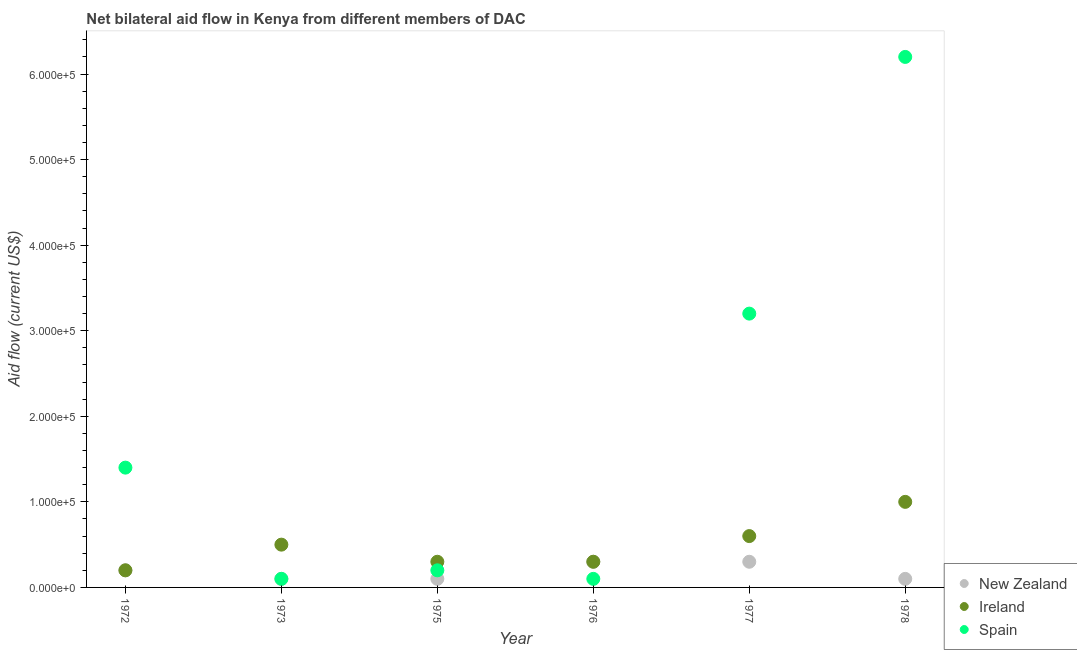How many different coloured dotlines are there?
Your answer should be very brief. 3. Is the number of dotlines equal to the number of legend labels?
Keep it short and to the point. Yes. What is the amount of aid provided by new zealand in 1972?
Offer a terse response. 2.00e+04. Across all years, what is the maximum amount of aid provided by spain?
Your answer should be compact. 6.20e+05. Across all years, what is the minimum amount of aid provided by new zealand?
Ensure brevity in your answer.  10000. In which year was the amount of aid provided by spain maximum?
Provide a succinct answer. 1978. In which year was the amount of aid provided by new zealand minimum?
Give a very brief answer. 1973. What is the total amount of aid provided by spain in the graph?
Give a very brief answer. 1.12e+06. What is the difference between the amount of aid provided by spain in 1976 and that in 1977?
Give a very brief answer. -3.10e+05. What is the difference between the amount of aid provided by spain in 1975 and the amount of aid provided by ireland in 1973?
Keep it short and to the point. -3.00e+04. What is the average amount of aid provided by spain per year?
Your answer should be very brief. 1.87e+05. In the year 1978, what is the difference between the amount of aid provided by new zealand and amount of aid provided by spain?
Ensure brevity in your answer.  -6.10e+05. In how many years, is the amount of aid provided by ireland greater than 480000 US$?
Provide a succinct answer. 0. Is the difference between the amount of aid provided by ireland in 1975 and 1978 greater than the difference between the amount of aid provided by new zealand in 1975 and 1978?
Offer a very short reply. No. What is the difference between the highest and the second highest amount of aid provided by new zealand?
Keep it short and to the point. 0. What is the difference between the highest and the lowest amount of aid provided by spain?
Your response must be concise. 6.10e+05. Is it the case that in every year, the sum of the amount of aid provided by new zealand and amount of aid provided by ireland is greater than the amount of aid provided by spain?
Offer a very short reply. No. How many years are there in the graph?
Offer a very short reply. 6. Does the graph contain any zero values?
Make the answer very short. No. How are the legend labels stacked?
Your answer should be very brief. Vertical. What is the title of the graph?
Your answer should be compact. Net bilateral aid flow in Kenya from different members of DAC. What is the label or title of the Y-axis?
Your answer should be very brief. Aid flow (current US$). What is the Aid flow (current US$) in New Zealand in 1972?
Offer a very short reply. 2.00e+04. What is the Aid flow (current US$) of Ireland in 1972?
Make the answer very short. 2.00e+04. What is the Aid flow (current US$) of Spain in 1972?
Your answer should be compact. 1.40e+05. What is the Aid flow (current US$) in New Zealand in 1973?
Keep it short and to the point. 10000. What is the Aid flow (current US$) in Ireland in 1973?
Offer a very short reply. 5.00e+04. What is the Aid flow (current US$) in Spain in 1973?
Provide a succinct answer. 10000. What is the Aid flow (current US$) in New Zealand in 1975?
Provide a short and direct response. 10000. What is the Aid flow (current US$) in Spain in 1975?
Ensure brevity in your answer.  2.00e+04. What is the Aid flow (current US$) of New Zealand in 1976?
Keep it short and to the point. 3.00e+04. What is the Aid flow (current US$) in Spain in 1976?
Your answer should be compact. 10000. What is the Aid flow (current US$) in New Zealand in 1977?
Give a very brief answer. 3.00e+04. What is the Aid flow (current US$) in Ireland in 1977?
Your answer should be very brief. 6.00e+04. What is the Aid flow (current US$) in Spain in 1977?
Ensure brevity in your answer.  3.20e+05. What is the Aid flow (current US$) in New Zealand in 1978?
Your response must be concise. 10000. What is the Aid flow (current US$) of Spain in 1978?
Your response must be concise. 6.20e+05. Across all years, what is the maximum Aid flow (current US$) of New Zealand?
Keep it short and to the point. 3.00e+04. Across all years, what is the maximum Aid flow (current US$) in Spain?
Provide a succinct answer. 6.20e+05. Across all years, what is the minimum Aid flow (current US$) in Spain?
Offer a very short reply. 10000. What is the total Aid flow (current US$) in New Zealand in the graph?
Make the answer very short. 1.10e+05. What is the total Aid flow (current US$) in Spain in the graph?
Ensure brevity in your answer.  1.12e+06. What is the difference between the Aid flow (current US$) in New Zealand in 1972 and that in 1973?
Offer a very short reply. 10000. What is the difference between the Aid flow (current US$) of Ireland in 1972 and that in 1973?
Provide a succinct answer. -3.00e+04. What is the difference between the Aid flow (current US$) of Spain in 1972 and that in 1973?
Offer a terse response. 1.30e+05. What is the difference between the Aid flow (current US$) of Ireland in 1972 and that in 1975?
Offer a terse response. -10000. What is the difference between the Aid flow (current US$) of Ireland in 1972 and that in 1976?
Offer a terse response. -10000. What is the difference between the Aid flow (current US$) in Spain in 1972 and that in 1976?
Ensure brevity in your answer.  1.30e+05. What is the difference between the Aid flow (current US$) of Ireland in 1972 and that in 1977?
Offer a very short reply. -4.00e+04. What is the difference between the Aid flow (current US$) of Spain in 1972 and that in 1978?
Your answer should be very brief. -4.80e+05. What is the difference between the Aid flow (current US$) in New Zealand in 1973 and that in 1976?
Provide a short and direct response. -2.00e+04. What is the difference between the Aid flow (current US$) in Ireland in 1973 and that in 1976?
Your response must be concise. 2.00e+04. What is the difference between the Aid flow (current US$) in Spain in 1973 and that in 1976?
Your answer should be compact. 0. What is the difference between the Aid flow (current US$) of New Zealand in 1973 and that in 1977?
Provide a succinct answer. -2.00e+04. What is the difference between the Aid flow (current US$) of Spain in 1973 and that in 1977?
Make the answer very short. -3.10e+05. What is the difference between the Aid flow (current US$) in New Zealand in 1973 and that in 1978?
Keep it short and to the point. 0. What is the difference between the Aid flow (current US$) in Spain in 1973 and that in 1978?
Give a very brief answer. -6.10e+05. What is the difference between the Aid flow (current US$) in Ireland in 1975 and that in 1976?
Keep it short and to the point. 0. What is the difference between the Aid flow (current US$) of Spain in 1975 and that in 1976?
Keep it short and to the point. 10000. What is the difference between the Aid flow (current US$) of New Zealand in 1975 and that in 1977?
Your response must be concise. -2.00e+04. What is the difference between the Aid flow (current US$) of Spain in 1975 and that in 1978?
Your answer should be compact. -6.00e+05. What is the difference between the Aid flow (current US$) of New Zealand in 1976 and that in 1977?
Provide a short and direct response. 0. What is the difference between the Aid flow (current US$) in Spain in 1976 and that in 1977?
Your answer should be compact. -3.10e+05. What is the difference between the Aid flow (current US$) of Spain in 1976 and that in 1978?
Your answer should be compact. -6.10e+05. What is the difference between the Aid flow (current US$) of New Zealand in 1977 and that in 1978?
Your response must be concise. 2.00e+04. What is the difference between the Aid flow (current US$) in Ireland in 1977 and that in 1978?
Offer a terse response. -4.00e+04. What is the difference between the Aid flow (current US$) of Ireland in 1972 and the Aid flow (current US$) of Spain in 1973?
Your answer should be compact. 10000. What is the difference between the Aid flow (current US$) of New Zealand in 1972 and the Aid flow (current US$) of Ireland in 1975?
Your answer should be compact. -10000. What is the difference between the Aid flow (current US$) of New Zealand in 1972 and the Aid flow (current US$) of Spain in 1975?
Keep it short and to the point. 0. What is the difference between the Aid flow (current US$) in New Zealand in 1972 and the Aid flow (current US$) in Spain in 1976?
Provide a short and direct response. 10000. What is the difference between the Aid flow (current US$) in Ireland in 1972 and the Aid flow (current US$) in Spain in 1976?
Ensure brevity in your answer.  10000. What is the difference between the Aid flow (current US$) of Ireland in 1972 and the Aid flow (current US$) of Spain in 1977?
Your response must be concise. -3.00e+05. What is the difference between the Aid flow (current US$) in New Zealand in 1972 and the Aid flow (current US$) in Spain in 1978?
Provide a succinct answer. -6.00e+05. What is the difference between the Aid flow (current US$) of Ireland in 1972 and the Aid flow (current US$) of Spain in 1978?
Offer a terse response. -6.00e+05. What is the difference between the Aid flow (current US$) in New Zealand in 1973 and the Aid flow (current US$) in Spain in 1975?
Your response must be concise. -10000. What is the difference between the Aid flow (current US$) in New Zealand in 1973 and the Aid flow (current US$) in Ireland in 1976?
Provide a succinct answer. -2.00e+04. What is the difference between the Aid flow (current US$) of New Zealand in 1973 and the Aid flow (current US$) of Spain in 1977?
Offer a terse response. -3.10e+05. What is the difference between the Aid flow (current US$) of New Zealand in 1973 and the Aid flow (current US$) of Spain in 1978?
Your answer should be very brief. -6.10e+05. What is the difference between the Aid flow (current US$) of Ireland in 1973 and the Aid flow (current US$) of Spain in 1978?
Your response must be concise. -5.70e+05. What is the difference between the Aid flow (current US$) of New Zealand in 1975 and the Aid flow (current US$) of Ireland in 1976?
Your response must be concise. -2.00e+04. What is the difference between the Aid flow (current US$) in New Zealand in 1975 and the Aid flow (current US$) in Spain in 1977?
Your response must be concise. -3.10e+05. What is the difference between the Aid flow (current US$) in New Zealand in 1975 and the Aid flow (current US$) in Spain in 1978?
Give a very brief answer. -6.10e+05. What is the difference between the Aid flow (current US$) in Ireland in 1975 and the Aid flow (current US$) in Spain in 1978?
Offer a terse response. -5.90e+05. What is the difference between the Aid flow (current US$) in New Zealand in 1976 and the Aid flow (current US$) in Spain in 1977?
Give a very brief answer. -2.90e+05. What is the difference between the Aid flow (current US$) in New Zealand in 1976 and the Aid flow (current US$) in Spain in 1978?
Give a very brief answer. -5.90e+05. What is the difference between the Aid flow (current US$) in Ireland in 1976 and the Aid flow (current US$) in Spain in 1978?
Provide a succinct answer. -5.90e+05. What is the difference between the Aid flow (current US$) of New Zealand in 1977 and the Aid flow (current US$) of Spain in 1978?
Your answer should be compact. -5.90e+05. What is the difference between the Aid flow (current US$) in Ireland in 1977 and the Aid flow (current US$) in Spain in 1978?
Provide a short and direct response. -5.60e+05. What is the average Aid flow (current US$) in New Zealand per year?
Offer a terse response. 1.83e+04. What is the average Aid flow (current US$) of Ireland per year?
Give a very brief answer. 4.83e+04. What is the average Aid flow (current US$) of Spain per year?
Provide a short and direct response. 1.87e+05. In the year 1972, what is the difference between the Aid flow (current US$) in Ireland and Aid flow (current US$) in Spain?
Provide a succinct answer. -1.20e+05. In the year 1973, what is the difference between the Aid flow (current US$) of New Zealand and Aid flow (current US$) of Spain?
Your answer should be compact. 0. In the year 1973, what is the difference between the Aid flow (current US$) of Ireland and Aid flow (current US$) of Spain?
Provide a succinct answer. 4.00e+04. In the year 1975, what is the difference between the Aid flow (current US$) of New Zealand and Aid flow (current US$) of Ireland?
Your response must be concise. -2.00e+04. In the year 1975, what is the difference between the Aid flow (current US$) of New Zealand and Aid flow (current US$) of Spain?
Provide a succinct answer. -10000. In the year 1976, what is the difference between the Aid flow (current US$) in New Zealand and Aid flow (current US$) in Spain?
Offer a very short reply. 2.00e+04. In the year 1977, what is the difference between the Aid flow (current US$) of New Zealand and Aid flow (current US$) of Ireland?
Provide a short and direct response. -3.00e+04. In the year 1977, what is the difference between the Aid flow (current US$) in New Zealand and Aid flow (current US$) in Spain?
Your answer should be very brief. -2.90e+05. In the year 1978, what is the difference between the Aid flow (current US$) of New Zealand and Aid flow (current US$) of Ireland?
Ensure brevity in your answer.  -9.00e+04. In the year 1978, what is the difference between the Aid flow (current US$) of New Zealand and Aid flow (current US$) of Spain?
Your answer should be very brief. -6.10e+05. In the year 1978, what is the difference between the Aid flow (current US$) of Ireland and Aid flow (current US$) of Spain?
Keep it short and to the point. -5.20e+05. What is the ratio of the Aid flow (current US$) in New Zealand in 1972 to that in 1973?
Your answer should be compact. 2. What is the ratio of the Aid flow (current US$) of Ireland in 1972 to that in 1973?
Offer a very short reply. 0.4. What is the ratio of the Aid flow (current US$) in Spain in 1972 to that in 1973?
Provide a short and direct response. 14. What is the ratio of the Aid flow (current US$) of Ireland in 1972 to that in 1975?
Your answer should be compact. 0.67. What is the ratio of the Aid flow (current US$) of Ireland in 1972 to that in 1976?
Your response must be concise. 0.67. What is the ratio of the Aid flow (current US$) of Spain in 1972 to that in 1976?
Offer a very short reply. 14. What is the ratio of the Aid flow (current US$) in New Zealand in 1972 to that in 1977?
Your answer should be very brief. 0.67. What is the ratio of the Aid flow (current US$) of Ireland in 1972 to that in 1977?
Provide a short and direct response. 0.33. What is the ratio of the Aid flow (current US$) of Spain in 1972 to that in 1977?
Ensure brevity in your answer.  0.44. What is the ratio of the Aid flow (current US$) in Spain in 1972 to that in 1978?
Your response must be concise. 0.23. What is the ratio of the Aid flow (current US$) in New Zealand in 1973 to that in 1975?
Offer a terse response. 1. What is the ratio of the Aid flow (current US$) in Ireland in 1973 to that in 1975?
Your response must be concise. 1.67. What is the ratio of the Aid flow (current US$) in Spain in 1973 to that in 1975?
Ensure brevity in your answer.  0.5. What is the ratio of the Aid flow (current US$) in New Zealand in 1973 to that in 1976?
Your response must be concise. 0.33. What is the ratio of the Aid flow (current US$) of Ireland in 1973 to that in 1976?
Your answer should be very brief. 1.67. What is the ratio of the Aid flow (current US$) of Spain in 1973 to that in 1976?
Provide a succinct answer. 1. What is the ratio of the Aid flow (current US$) of Ireland in 1973 to that in 1977?
Offer a very short reply. 0.83. What is the ratio of the Aid flow (current US$) in Spain in 1973 to that in 1977?
Make the answer very short. 0.03. What is the ratio of the Aid flow (current US$) of Ireland in 1973 to that in 1978?
Make the answer very short. 0.5. What is the ratio of the Aid flow (current US$) of Spain in 1973 to that in 1978?
Your response must be concise. 0.02. What is the ratio of the Aid flow (current US$) in New Zealand in 1975 to that in 1976?
Offer a very short reply. 0.33. What is the ratio of the Aid flow (current US$) of Ireland in 1975 to that in 1976?
Ensure brevity in your answer.  1. What is the ratio of the Aid flow (current US$) in Spain in 1975 to that in 1976?
Offer a terse response. 2. What is the ratio of the Aid flow (current US$) of New Zealand in 1975 to that in 1977?
Ensure brevity in your answer.  0.33. What is the ratio of the Aid flow (current US$) of Spain in 1975 to that in 1977?
Provide a succinct answer. 0.06. What is the ratio of the Aid flow (current US$) in Ireland in 1975 to that in 1978?
Keep it short and to the point. 0.3. What is the ratio of the Aid flow (current US$) in Spain in 1975 to that in 1978?
Provide a short and direct response. 0.03. What is the ratio of the Aid flow (current US$) of Ireland in 1976 to that in 1977?
Provide a succinct answer. 0.5. What is the ratio of the Aid flow (current US$) of Spain in 1976 to that in 1977?
Offer a very short reply. 0.03. What is the ratio of the Aid flow (current US$) in New Zealand in 1976 to that in 1978?
Provide a short and direct response. 3. What is the ratio of the Aid flow (current US$) of Spain in 1976 to that in 1978?
Your answer should be very brief. 0.02. What is the ratio of the Aid flow (current US$) of Spain in 1977 to that in 1978?
Keep it short and to the point. 0.52. What is the difference between the highest and the second highest Aid flow (current US$) of New Zealand?
Ensure brevity in your answer.  0. What is the difference between the highest and the second highest Aid flow (current US$) of Ireland?
Offer a very short reply. 4.00e+04. What is the difference between the highest and the second highest Aid flow (current US$) of Spain?
Provide a short and direct response. 3.00e+05. What is the difference between the highest and the lowest Aid flow (current US$) in Spain?
Offer a very short reply. 6.10e+05. 